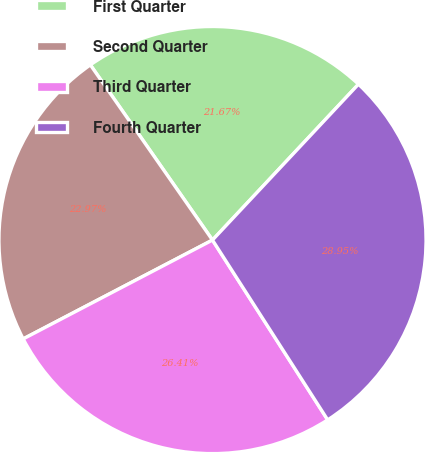Convert chart. <chart><loc_0><loc_0><loc_500><loc_500><pie_chart><fcel>First Quarter<fcel>Second Quarter<fcel>Third Quarter<fcel>Fourth Quarter<nl><fcel>21.67%<fcel>22.97%<fcel>26.41%<fcel>28.95%<nl></chart> 